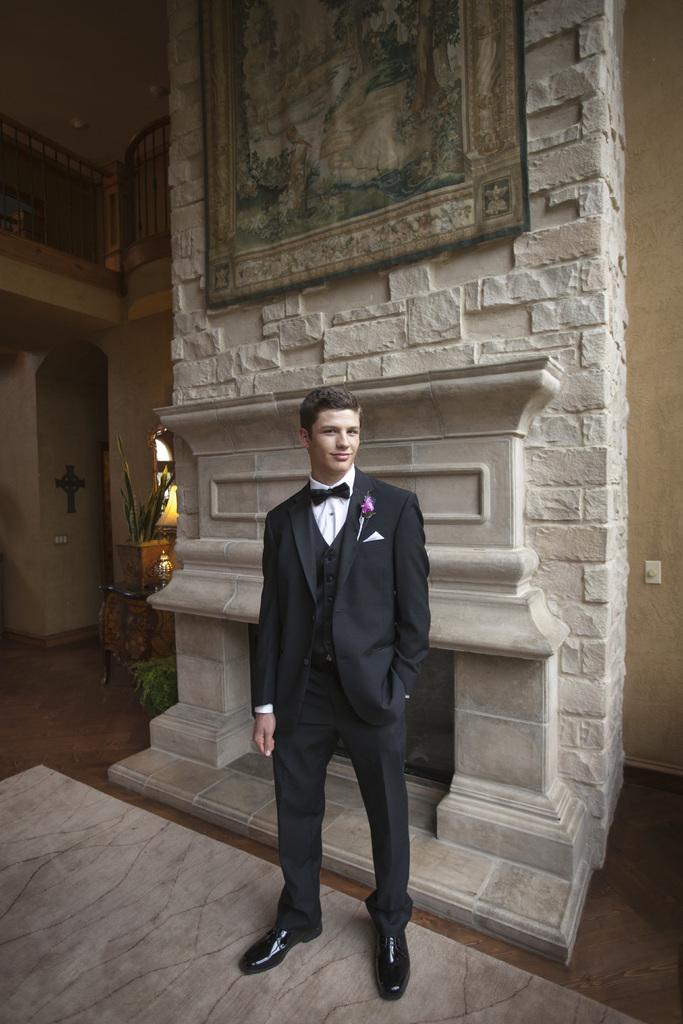Describe this image in one or two sentences. In this image, there is person wearing clothes and standing in front of the fire place. There is an art at the top of the image. 